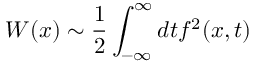<formula> <loc_0><loc_0><loc_500><loc_500>W ( x ) \sim \frac { 1 } { 2 } \int _ { - \infty } ^ { \infty } d t f ^ { 2 } ( x , t )</formula> 